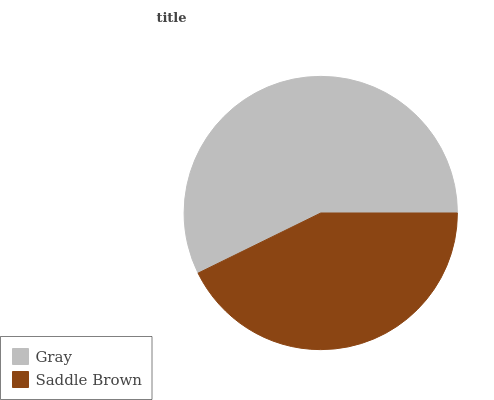Is Saddle Brown the minimum?
Answer yes or no. Yes. Is Gray the maximum?
Answer yes or no. Yes. Is Saddle Brown the maximum?
Answer yes or no. No. Is Gray greater than Saddle Brown?
Answer yes or no. Yes. Is Saddle Brown less than Gray?
Answer yes or no. Yes. Is Saddle Brown greater than Gray?
Answer yes or no. No. Is Gray less than Saddle Brown?
Answer yes or no. No. Is Gray the high median?
Answer yes or no. Yes. Is Saddle Brown the low median?
Answer yes or no. Yes. Is Saddle Brown the high median?
Answer yes or no. No. Is Gray the low median?
Answer yes or no. No. 